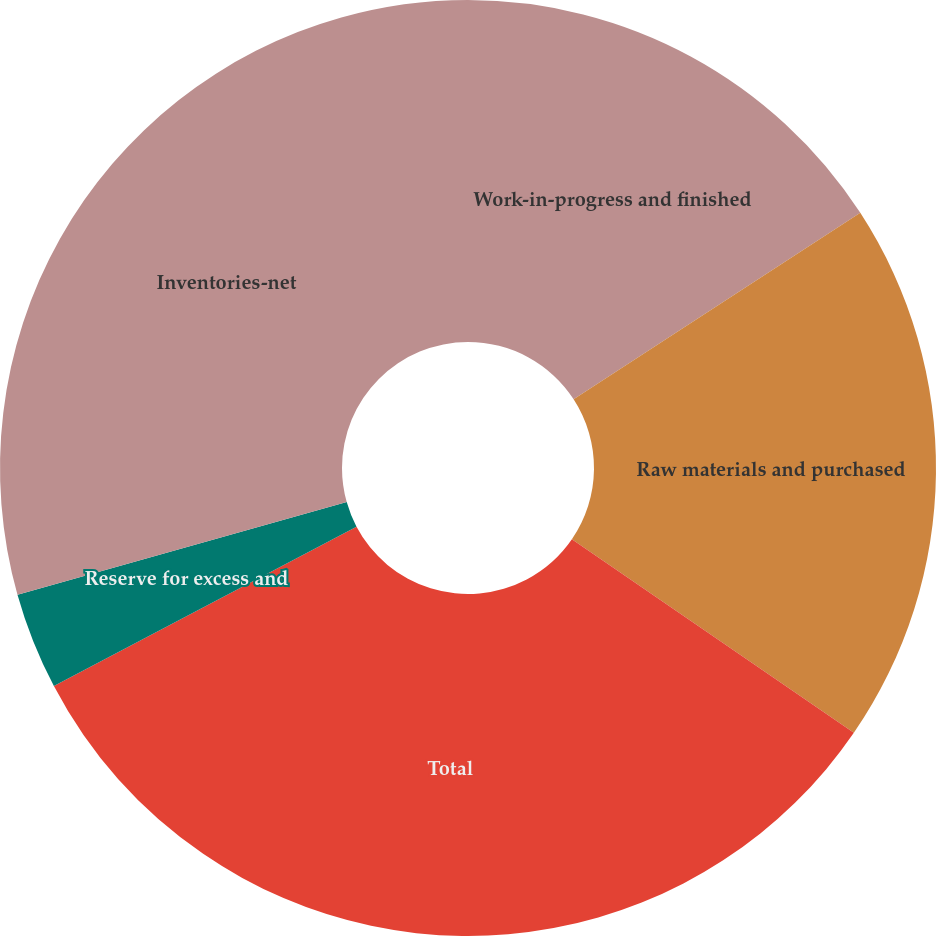Convert chart. <chart><loc_0><loc_0><loc_500><loc_500><pie_chart><fcel>Work-in-progress and finished<fcel>Raw materials and purchased<fcel>Total<fcel>Reserve for excess and<fcel>Inventories-net<nl><fcel>15.82%<fcel>18.75%<fcel>32.71%<fcel>3.35%<fcel>29.36%<nl></chart> 